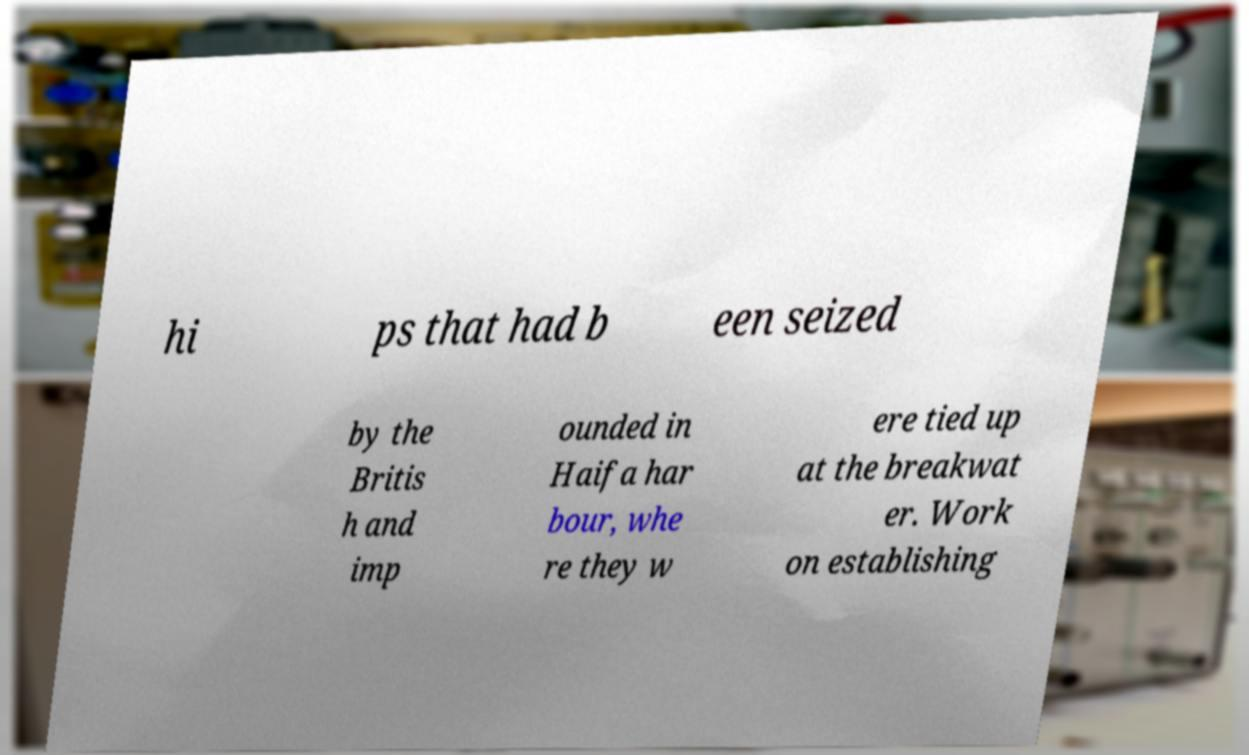Could you assist in decoding the text presented in this image and type it out clearly? hi ps that had b een seized by the Britis h and imp ounded in Haifa har bour, whe re they w ere tied up at the breakwat er. Work on establishing 